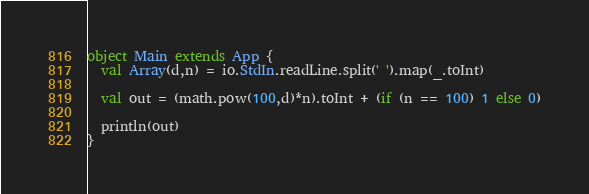Convert code to text. <code><loc_0><loc_0><loc_500><loc_500><_Scala_>object Main extends App {
  val Array(d,n) = io.StdIn.readLine.split(' ').map(_.toInt)

  val out = (math.pow(100,d)*n).toInt + (if (n == 100) 1 else 0)

  println(out)
}
</code> 